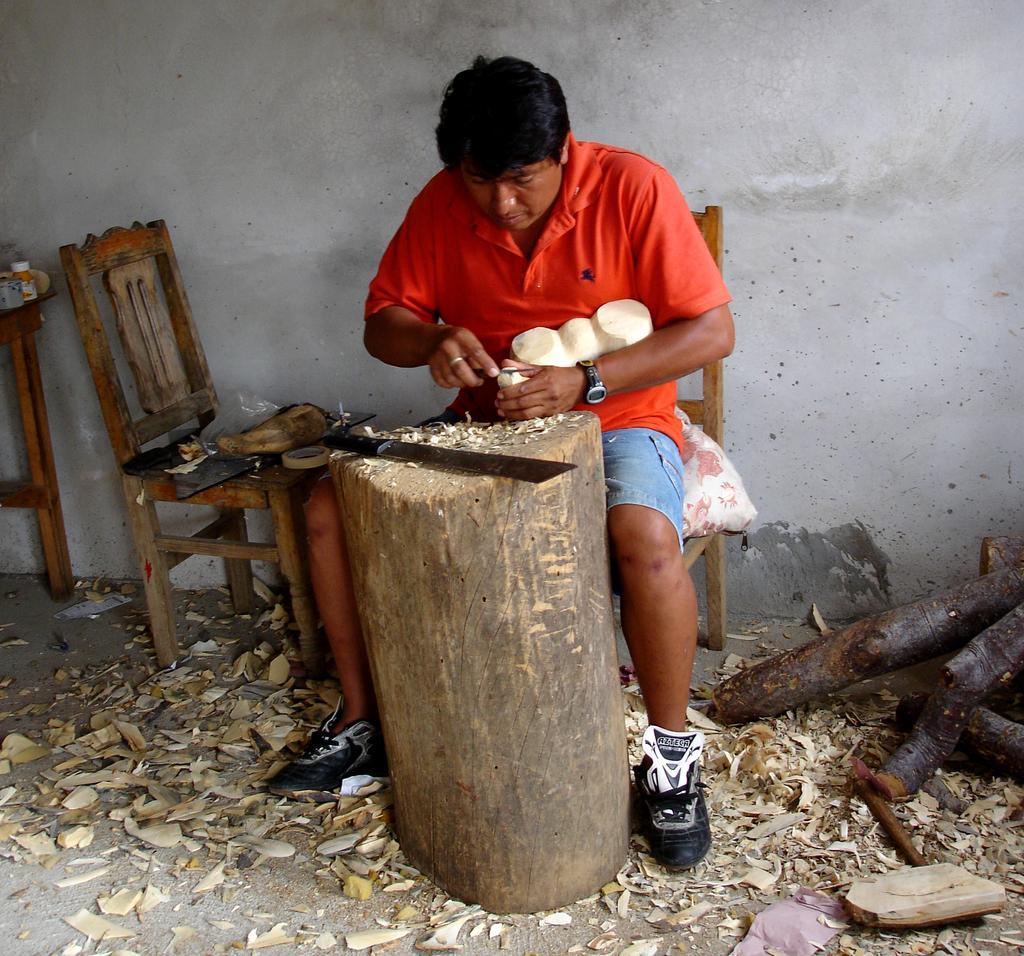Please provide a concise description of this image. This person is sitting on a chair. In-front of this person there is a wood. On a wood there is a sword. On floor there are tree stems. 